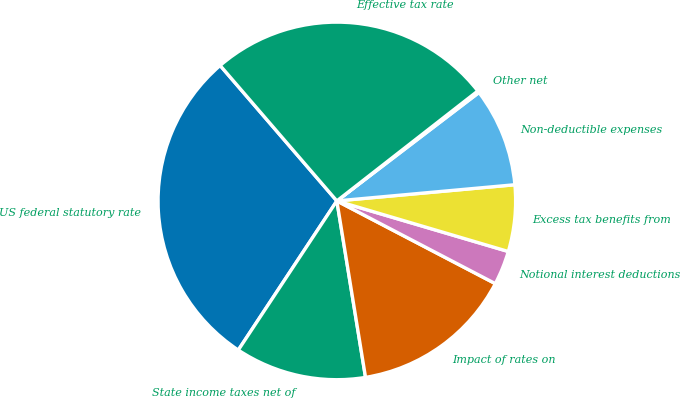Convert chart to OTSL. <chart><loc_0><loc_0><loc_500><loc_500><pie_chart><fcel>US federal statutory rate<fcel>State income taxes net of<fcel>Impact of rates on<fcel>Notional interest deductions<fcel>Excess tax benefits from<fcel>Non-deductible expenses<fcel>Other net<fcel>Effective tax rate<nl><fcel>29.39%<fcel>11.86%<fcel>14.78%<fcel>3.09%<fcel>6.01%<fcel>8.93%<fcel>0.17%<fcel>25.78%<nl></chart> 